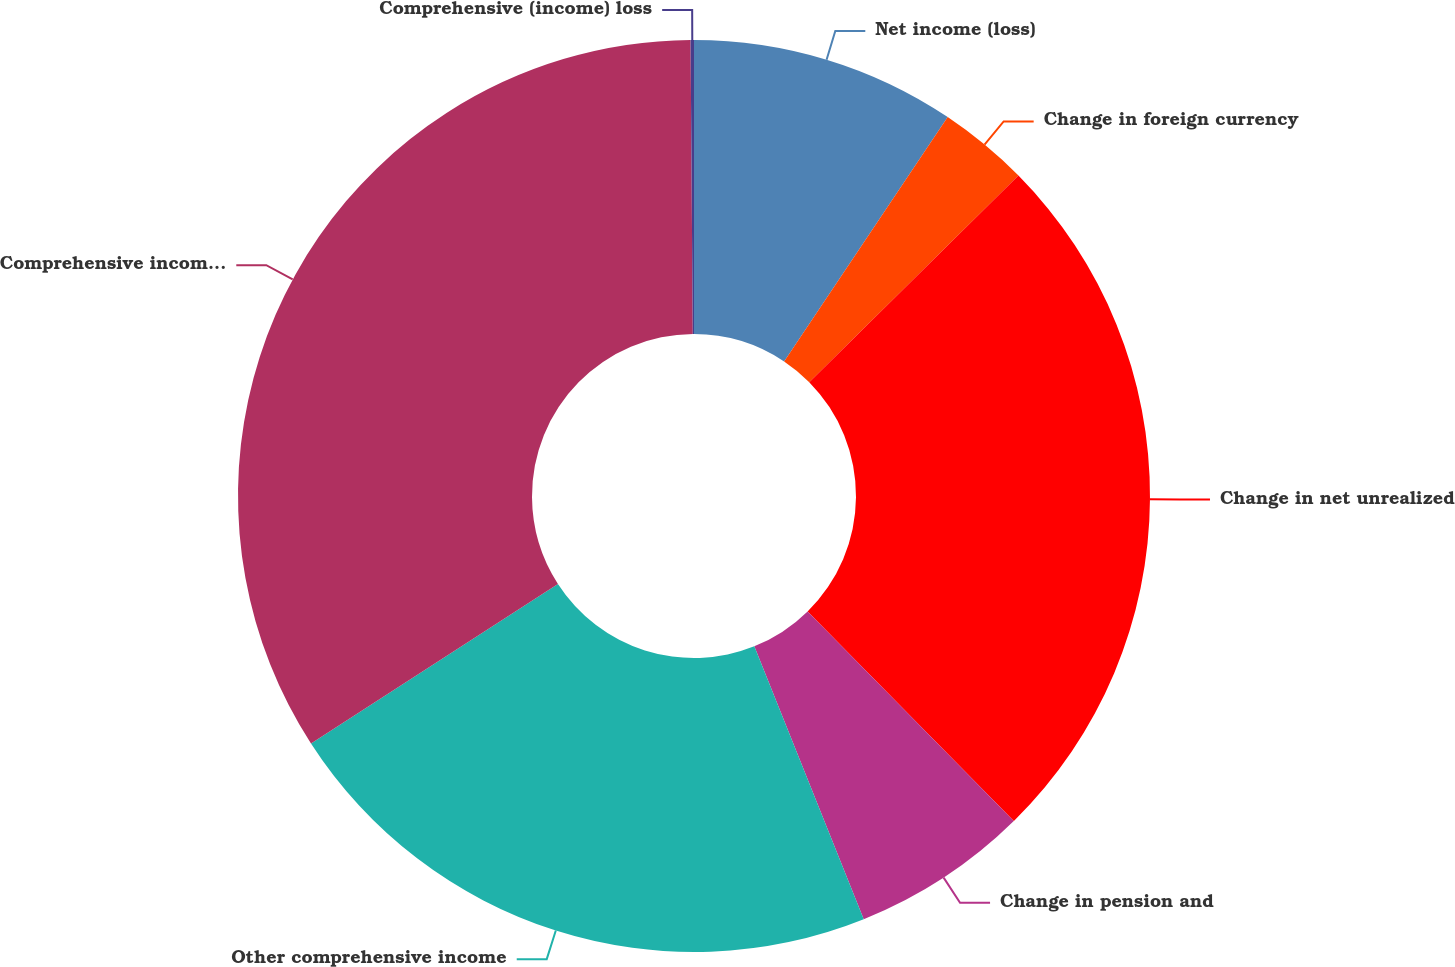<chart> <loc_0><loc_0><loc_500><loc_500><pie_chart><fcel>Net income (loss)<fcel>Change in foreign currency<fcel>Change in net unrealized<fcel>Change in pension and<fcel>Other comprehensive income<fcel>Comprehensive income (loss)<fcel>Comprehensive (income) loss<nl><fcel>9.39%<fcel>3.21%<fcel>25.03%<fcel>6.3%<fcel>21.94%<fcel>34.01%<fcel>0.12%<nl></chart> 